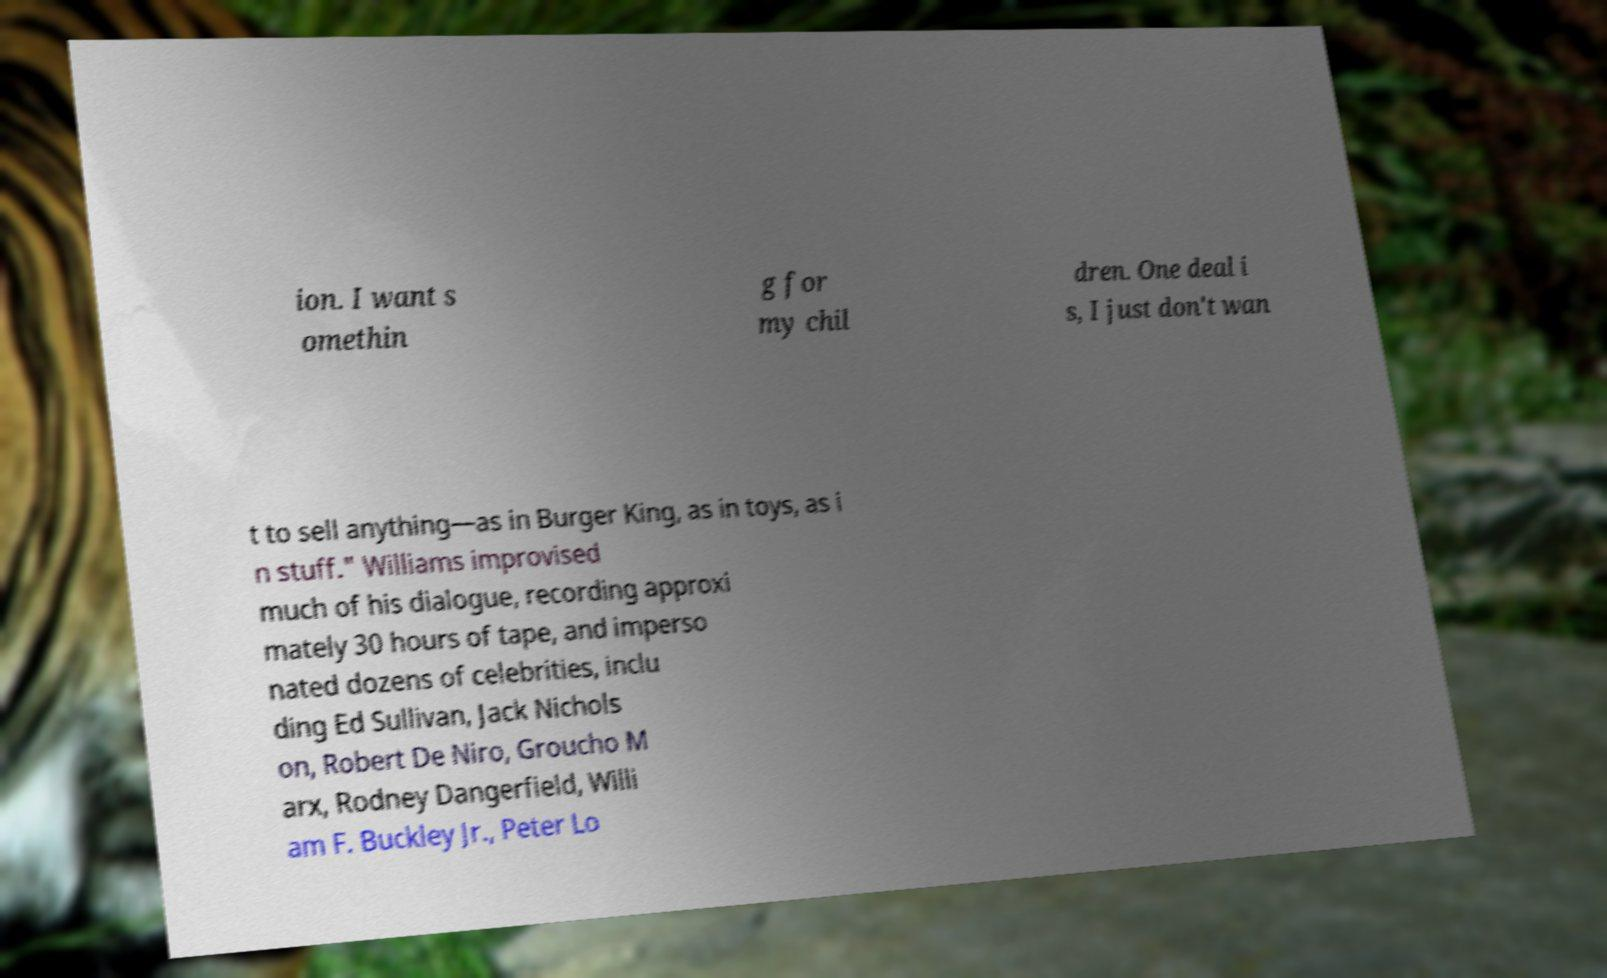Can you read and provide the text displayed in the image?This photo seems to have some interesting text. Can you extract and type it out for me? ion. I want s omethin g for my chil dren. One deal i s, I just don't wan t to sell anything—as in Burger King, as in toys, as i n stuff." Williams improvised much of his dialogue, recording approxi mately 30 hours of tape, and imperso nated dozens of celebrities, inclu ding Ed Sullivan, Jack Nichols on, Robert De Niro, Groucho M arx, Rodney Dangerfield, Willi am F. Buckley Jr., Peter Lo 